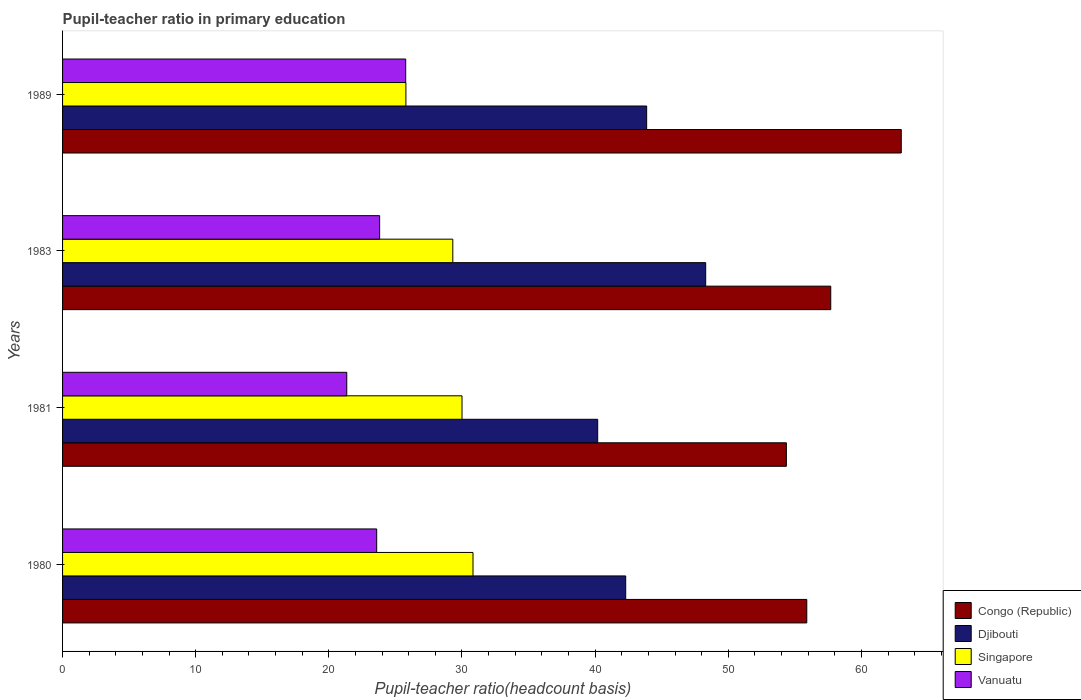How many different coloured bars are there?
Your response must be concise. 4. Are the number of bars per tick equal to the number of legend labels?
Keep it short and to the point. Yes. In how many cases, is the number of bars for a given year not equal to the number of legend labels?
Your response must be concise. 0. What is the pupil-teacher ratio in primary education in Congo (Republic) in 1983?
Make the answer very short. 57.7. Across all years, what is the maximum pupil-teacher ratio in primary education in Congo (Republic)?
Keep it short and to the point. 63. Across all years, what is the minimum pupil-teacher ratio in primary education in Congo (Republic)?
Offer a very short reply. 54.37. What is the total pupil-teacher ratio in primary education in Vanuatu in the graph?
Provide a succinct answer. 94.53. What is the difference between the pupil-teacher ratio in primary education in Vanuatu in 1980 and that in 1981?
Your response must be concise. 2.25. What is the difference between the pupil-teacher ratio in primary education in Congo (Republic) in 1983 and the pupil-teacher ratio in primary education in Djibouti in 1989?
Offer a very short reply. 13.83. What is the average pupil-teacher ratio in primary education in Singapore per year?
Provide a short and direct response. 28.98. In the year 1981, what is the difference between the pupil-teacher ratio in primary education in Vanuatu and pupil-teacher ratio in primary education in Djibouti?
Provide a succinct answer. -18.85. In how many years, is the pupil-teacher ratio in primary education in Djibouti greater than 54 ?
Ensure brevity in your answer.  0. What is the ratio of the pupil-teacher ratio in primary education in Vanuatu in 1980 to that in 1983?
Your answer should be compact. 0.99. Is the pupil-teacher ratio in primary education in Congo (Republic) in 1980 less than that in 1981?
Give a very brief answer. No. Is the difference between the pupil-teacher ratio in primary education in Vanuatu in 1980 and 1983 greater than the difference between the pupil-teacher ratio in primary education in Djibouti in 1980 and 1983?
Provide a succinct answer. Yes. What is the difference between the highest and the second highest pupil-teacher ratio in primary education in Djibouti?
Your answer should be very brief. 4.43. What is the difference between the highest and the lowest pupil-teacher ratio in primary education in Singapore?
Make the answer very short. 5.04. Is the sum of the pupil-teacher ratio in primary education in Singapore in 1981 and 1989 greater than the maximum pupil-teacher ratio in primary education in Djibouti across all years?
Keep it short and to the point. Yes. Is it the case that in every year, the sum of the pupil-teacher ratio in primary education in Singapore and pupil-teacher ratio in primary education in Congo (Republic) is greater than the sum of pupil-teacher ratio in primary education in Vanuatu and pupil-teacher ratio in primary education in Djibouti?
Make the answer very short. No. What does the 1st bar from the top in 1983 represents?
Offer a very short reply. Vanuatu. What does the 3rd bar from the bottom in 1981 represents?
Provide a succinct answer. Singapore. Is it the case that in every year, the sum of the pupil-teacher ratio in primary education in Congo (Republic) and pupil-teacher ratio in primary education in Djibouti is greater than the pupil-teacher ratio in primary education in Vanuatu?
Ensure brevity in your answer.  Yes. How many bars are there?
Keep it short and to the point. 16. What is the difference between two consecutive major ticks on the X-axis?
Offer a terse response. 10. Does the graph contain any zero values?
Your answer should be very brief. No. Does the graph contain grids?
Your response must be concise. No. What is the title of the graph?
Ensure brevity in your answer.  Pupil-teacher ratio in primary education. What is the label or title of the X-axis?
Offer a very short reply. Pupil-teacher ratio(headcount basis). What is the label or title of the Y-axis?
Keep it short and to the point. Years. What is the Pupil-teacher ratio(headcount basis) of Congo (Republic) in 1980?
Your response must be concise. 55.9. What is the Pupil-teacher ratio(headcount basis) of Djibouti in 1980?
Provide a short and direct response. 42.3. What is the Pupil-teacher ratio(headcount basis) of Singapore in 1980?
Make the answer very short. 30.83. What is the Pupil-teacher ratio(headcount basis) in Vanuatu in 1980?
Your answer should be compact. 23.59. What is the Pupil-teacher ratio(headcount basis) in Congo (Republic) in 1981?
Make the answer very short. 54.37. What is the Pupil-teacher ratio(headcount basis) in Djibouti in 1981?
Provide a succinct answer. 40.19. What is the Pupil-teacher ratio(headcount basis) of Singapore in 1981?
Your answer should be very brief. 30. What is the Pupil-teacher ratio(headcount basis) in Vanuatu in 1981?
Your response must be concise. 21.35. What is the Pupil-teacher ratio(headcount basis) of Congo (Republic) in 1983?
Give a very brief answer. 57.7. What is the Pupil-teacher ratio(headcount basis) of Djibouti in 1983?
Provide a short and direct response. 48.3. What is the Pupil-teacher ratio(headcount basis) in Singapore in 1983?
Your answer should be very brief. 29.31. What is the Pupil-teacher ratio(headcount basis) in Vanuatu in 1983?
Offer a very short reply. 23.82. What is the Pupil-teacher ratio(headcount basis) in Congo (Republic) in 1989?
Give a very brief answer. 63. What is the Pupil-teacher ratio(headcount basis) in Djibouti in 1989?
Give a very brief answer. 43.87. What is the Pupil-teacher ratio(headcount basis) in Singapore in 1989?
Your answer should be compact. 25.79. What is the Pupil-teacher ratio(headcount basis) of Vanuatu in 1989?
Ensure brevity in your answer.  25.77. Across all years, what is the maximum Pupil-teacher ratio(headcount basis) of Congo (Republic)?
Offer a very short reply. 63. Across all years, what is the maximum Pupil-teacher ratio(headcount basis) in Djibouti?
Give a very brief answer. 48.3. Across all years, what is the maximum Pupil-teacher ratio(headcount basis) in Singapore?
Ensure brevity in your answer.  30.83. Across all years, what is the maximum Pupil-teacher ratio(headcount basis) of Vanuatu?
Give a very brief answer. 25.77. Across all years, what is the minimum Pupil-teacher ratio(headcount basis) of Congo (Republic)?
Ensure brevity in your answer.  54.37. Across all years, what is the minimum Pupil-teacher ratio(headcount basis) in Djibouti?
Keep it short and to the point. 40.19. Across all years, what is the minimum Pupil-teacher ratio(headcount basis) of Singapore?
Offer a terse response. 25.79. Across all years, what is the minimum Pupil-teacher ratio(headcount basis) in Vanuatu?
Provide a succinct answer. 21.35. What is the total Pupil-teacher ratio(headcount basis) of Congo (Republic) in the graph?
Your answer should be compact. 230.96. What is the total Pupil-teacher ratio(headcount basis) of Djibouti in the graph?
Keep it short and to the point. 174.67. What is the total Pupil-teacher ratio(headcount basis) of Singapore in the graph?
Your answer should be very brief. 115.93. What is the total Pupil-teacher ratio(headcount basis) in Vanuatu in the graph?
Ensure brevity in your answer.  94.53. What is the difference between the Pupil-teacher ratio(headcount basis) in Congo (Republic) in 1980 and that in 1981?
Offer a very short reply. 1.53. What is the difference between the Pupil-teacher ratio(headcount basis) in Djibouti in 1980 and that in 1981?
Offer a terse response. 2.1. What is the difference between the Pupil-teacher ratio(headcount basis) in Singapore in 1980 and that in 1981?
Ensure brevity in your answer.  0.82. What is the difference between the Pupil-teacher ratio(headcount basis) in Vanuatu in 1980 and that in 1981?
Offer a very short reply. 2.25. What is the difference between the Pupil-teacher ratio(headcount basis) of Congo (Republic) in 1980 and that in 1983?
Your response must be concise. -1.8. What is the difference between the Pupil-teacher ratio(headcount basis) of Djibouti in 1980 and that in 1983?
Your answer should be compact. -6.01. What is the difference between the Pupil-teacher ratio(headcount basis) in Singapore in 1980 and that in 1983?
Provide a succinct answer. 1.52. What is the difference between the Pupil-teacher ratio(headcount basis) in Vanuatu in 1980 and that in 1983?
Keep it short and to the point. -0.22. What is the difference between the Pupil-teacher ratio(headcount basis) of Congo (Republic) in 1980 and that in 1989?
Offer a terse response. -7.1. What is the difference between the Pupil-teacher ratio(headcount basis) of Djibouti in 1980 and that in 1989?
Provide a short and direct response. -1.57. What is the difference between the Pupil-teacher ratio(headcount basis) in Singapore in 1980 and that in 1989?
Provide a short and direct response. 5.04. What is the difference between the Pupil-teacher ratio(headcount basis) in Vanuatu in 1980 and that in 1989?
Your answer should be very brief. -2.18. What is the difference between the Pupil-teacher ratio(headcount basis) in Congo (Republic) in 1981 and that in 1983?
Provide a succinct answer. -3.33. What is the difference between the Pupil-teacher ratio(headcount basis) of Djibouti in 1981 and that in 1983?
Your response must be concise. -8.11. What is the difference between the Pupil-teacher ratio(headcount basis) of Singapore in 1981 and that in 1983?
Your answer should be compact. 0.69. What is the difference between the Pupil-teacher ratio(headcount basis) of Vanuatu in 1981 and that in 1983?
Your answer should be very brief. -2.47. What is the difference between the Pupil-teacher ratio(headcount basis) in Congo (Republic) in 1981 and that in 1989?
Make the answer very short. -8.63. What is the difference between the Pupil-teacher ratio(headcount basis) of Djibouti in 1981 and that in 1989?
Your response must be concise. -3.68. What is the difference between the Pupil-teacher ratio(headcount basis) of Singapore in 1981 and that in 1989?
Give a very brief answer. 4.21. What is the difference between the Pupil-teacher ratio(headcount basis) in Vanuatu in 1981 and that in 1989?
Your answer should be compact. -4.43. What is the difference between the Pupil-teacher ratio(headcount basis) in Congo (Republic) in 1983 and that in 1989?
Your response must be concise. -5.3. What is the difference between the Pupil-teacher ratio(headcount basis) of Djibouti in 1983 and that in 1989?
Offer a terse response. 4.43. What is the difference between the Pupil-teacher ratio(headcount basis) of Singapore in 1983 and that in 1989?
Offer a terse response. 3.52. What is the difference between the Pupil-teacher ratio(headcount basis) of Vanuatu in 1983 and that in 1989?
Provide a succinct answer. -1.96. What is the difference between the Pupil-teacher ratio(headcount basis) in Congo (Republic) in 1980 and the Pupil-teacher ratio(headcount basis) in Djibouti in 1981?
Offer a terse response. 15.71. What is the difference between the Pupil-teacher ratio(headcount basis) of Congo (Republic) in 1980 and the Pupil-teacher ratio(headcount basis) of Singapore in 1981?
Provide a short and direct response. 25.9. What is the difference between the Pupil-teacher ratio(headcount basis) in Congo (Republic) in 1980 and the Pupil-teacher ratio(headcount basis) in Vanuatu in 1981?
Give a very brief answer. 34.55. What is the difference between the Pupil-teacher ratio(headcount basis) of Djibouti in 1980 and the Pupil-teacher ratio(headcount basis) of Singapore in 1981?
Your answer should be compact. 12.29. What is the difference between the Pupil-teacher ratio(headcount basis) in Djibouti in 1980 and the Pupil-teacher ratio(headcount basis) in Vanuatu in 1981?
Make the answer very short. 20.95. What is the difference between the Pupil-teacher ratio(headcount basis) of Singapore in 1980 and the Pupil-teacher ratio(headcount basis) of Vanuatu in 1981?
Your answer should be compact. 9.48. What is the difference between the Pupil-teacher ratio(headcount basis) of Congo (Republic) in 1980 and the Pupil-teacher ratio(headcount basis) of Djibouti in 1983?
Keep it short and to the point. 7.59. What is the difference between the Pupil-teacher ratio(headcount basis) of Congo (Republic) in 1980 and the Pupil-teacher ratio(headcount basis) of Singapore in 1983?
Offer a terse response. 26.59. What is the difference between the Pupil-teacher ratio(headcount basis) of Congo (Republic) in 1980 and the Pupil-teacher ratio(headcount basis) of Vanuatu in 1983?
Your answer should be compact. 32.08. What is the difference between the Pupil-teacher ratio(headcount basis) of Djibouti in 1980 and the Pupil-teacher ratio(headcount basis) of Singapore in 1983?
Your response must be concise. 12.99. What is the difference between the Pupil-teacher ratio(headcount basis) of Djibouti in 1980 and the Pupil-teacher ratio(headcount basis) of Vanuatu in 1983?
Give a very brief answer. 18.48. What is the difference between the Pupil-teacher ratio(headcount basis) in Singapore in 1980 and the Pupil-teacher ratio(headcount basis) in Vanuatu in 1983?
Your answer should be compact. 7.01. What is the difference between the Pupil-teacher ratio(headcount basis) in Congo (Republic) in 1980 and the Pupil-teacher ratio(headcount basis) in Djibouti in 1989?
Provide a succinct answer. 12.03. What is the difference between the Pupil-teacher ratio(headcount basis) in Congo (Republic) in 1980 and the Pupil-teacher ratio(headcount basis) in Singapore in 1989?
Make the answer very short. 30.11. What is the difference between the Pupil-teacher ratio(headcount basis) of Congo (Republic) in 1980 and the Pupil-teacher ratio(headcount basis) of Vanuatu in 1989?
Your response must be concise. 30.13. What is the difference between the Pupil-teacher ratio(headcount basis) of Djibouti in 1980 and the Pupil-teacher ratio(headcount basis) of Singapore in 1989?
Offer a terse response. 16.51. What is the difference between the Pupil-teacher ratio(headcount basis) in Djibouti in 1980 and the Pupil-teacher ratio(headcount basis) in Vanuatu in 1989?
Ensure brevity in your answer.  16.52. What is the difference between the Pupil-teacher ratio(headcount basis) of Singapore in 1980 and the Pupil-teacher ratio(headcount basis) of Vanuatu in 1989?
Your answer should be compact. 5.05. What is the difference between the Pupil-teacher ratio(headcount basis) in Congo (Republic) in 1981 and the Pupil-teacher ratio(headcount basis) in Djibouti in 1983?
Provide a succinct answer. 6.06. What is the difference between the Pupil-teacher ratio(headcount basis) in Congo (Republic) in 1981 and the Pupil-teacher ratio(headcount basis) in Singapore in 1983?
Offer a very short reply. 25.05. What is the difference between the Pupil-teacher ratio(headcount basis) of Congo (Republic) in 1981 and the Pupil-teacher ratio(headcount basis) of Vanuatu in 1983?
Your answer should be very brief. 30.55. What is the difference between the Pupil-teacher ratio(headcount basis) of Djibouti in 1981 and the Pupil-teacher ratio(headcount basis) of Singapore in 1983?
Your response must be concise. 10.88. What is the difference between the Pupil-teacher ratio(headcount basis) in Djibouti in 1981 and the Pupil-teacher ratio(headcount basis) in Vanuatu in 1983?
Provide a succinct answer. 16.38. What is the difference between the Pupil-teacher ratio(headcount basis) of Singapore in 1981 and the Pupil-teacher ratio(headcount basis) of Vanuatu in 1983?
Provide a succinct answer. 6.19. What is the difference between the Pupil-teacher ratio(headcount basis) of Congo (Republic) in 1981 and the Pupil-teacher ratio(headcount basis) of Djibouti in 1989?
Ensure brevity in your answer.  10.49. What is the difference between the Pupil-teacher ratio(headcount basis) of Congo (Republic) in 1981 and the Pupil-teacher ratio(headcount basis) of Singapore in 1989?
Offer a very short reply. 28.58. What is the difference between the Pupil-teacher ratio(headcount basis) in Congo (Republic) in 1981 and the Pupil-teacher ratio(headcount basis) in Vanuatu in 1989?
Your answer should be very brief. 28.59. What is the difference between the Pupil-teacher ratio(headcount basis) in Djibouti in 1981 and the Pupil-teacher ratio(headcount basis) in Singapore in 1989?
Offer a very short reply. 14.4. What is the difference between the Pupil-teacher ratio(headcount basis) in Djibouti in 1981 and the Pupil-teacher ratio(headcount basis) in Vanuatu in 1989?
Offer a terse response. 14.42. What is the difference between the Pupil-teacher ratio(headcount basis) in Singapore in 1981 and the Pupil-teacher ratio(headcount basis) in Vanuatu in 1989?
Your answer should be very brief. 4.23. What is the difference between the Pupil-teacher ratio(headcount basis) in Congo (Republic) in 1983 and the Pupil-teacher ratio(headcount basis) in Djibouti in 1989?
Provide a short and direct response. 13.83. What is the difference between the Pupil-teacher ratio(headcount basis) in Congo (Republic) in 1983 and the Pupil-teacher ratio(headcount basis) in Singapore in 1989?
Your answer should be compact. 31.91. What is the difference between the Pupil-teacher ratio(headcount basis) of Congo (Republic) in 1983 and the Pupil-teacher ratio(headcount basis) of Vanuatu in 1989?
Offer a terse response. 31.93. What is the difference between the Pupil-teacher ratio(headcount basis) of Djibouti in 1983 and the Pupil-teacher ratio(headcount basis) of Singapore in 1989?
Offer a very short reply. 22.52. What is the difference between the Pupil-teacher ratio(headcount basis) of Djibouti in 1983 and the Pupil-teacher ratio(headcount basis) of Vanuatu in 1989?
Provide a short and direct response. 22.53. What is the difference between the Pupil-teacher ratio(headcount basis) in Singapore in 1983 and the Pupil-teacher ratio(headcount basis) in Vanuatu in 1989?
Provide a succinct answer. 3.54. What is the average Pupil-teacher ratio(headcount basis) of Congo (Republic) per year?
Make the answer very short. 57.74. What is the average Pupil-teacher ratio(headcount basis) in Djibouti per year?
Make the answer very short. 43.67. What is the average Pupil-teacher ratio(headcount basis) in Singapore per year?
Ensure brevity in your answer.  28.98. What is the average Pupil-teacher ratio(headcount basis) of Vanuatu per year?
Your answer should be very brief. 23.63. In the year 1980, what is the difference between the Pupil-teacher ratio(headcount basis) of Congo (Republic) and Pupil-teacher ratio(headcount basis) of Djibouti?
Your answer should be very brief. 13.6. In the year 1980, what is the difference between the Pupil-teacher ratio(headcount basis) of Congo (Republic) and Pupil-teacher ratio(headcount basis) of Singapore?
Give a very brief answer. 25.07. In the year 1980, what is the difference between the Pupil-teacher ratio(headcount basis) of Congo (Republic) and Pupil-teacher ratio(headcount basis) of Vanuatu?
Ensure brevity in your answer.  32.3. In the year 1980, what is the difference between the Pupil-teacher ratio(headcount basis) in Djibouti and Pupil-teacher ratio(headcount basis) in Singapore?
Offer a terse response. 11.47. In the year 1980, what is the difference between the Pupil-teacher ratio(headcount basis) in Djibouti and Pupil-teacher ratio(headcount basis) in Vanuatu?
Make the answer very short. 18.7. In the year 1980, what is the difference between the Pupil-teacher ratio(headcount basis) in Singapore and Pupil-teacher ratio(headcount basis) in Vanuatu?
Give a very brief answer. 7.23. In the year 1981, what is the difference between the Pupil-teacher ratio(headcount basis) in Congo (Republic) and Pupil-teacher ratio(headcount basis) in Djibouti?
Your response must be concise. 14.17. In the year 1981, what is the difference between the Pupil-teacher ratio(headcount basis) in Congo (Republic) and Pupil-teacher ratio(headcount basis) in Singapore?
Your response must be concise. 24.36. In the year 1981, what is the difference between the Pupil-teacher ratio(headcount basis) in Congo (Republic) and Pupil-teacher ratio(headcount basis) in Vanuatu?
Keep it short and to the point. 33.02. In the year 1981, what is the difference between the Pupil-teacher ratio(headcount basis) of Djibouti and Pupil-teacher ratio(headcount basis) of Singapore?
Offer a terse response. 10.19. In the year 1981, what is the difference between the Pupil-teacher ratio(headcount basis) in Djibouti and Pupil-teacher ratio(headcount basis) in Vanuatu?
Your answer should be compact. 18.85. In the year 1981, what is the difference between the Pupil-teacher ratio(headcount basis) of Singapore and Pupil-teacher ratio(headcount basis) of Vanuatu?
Offer a terse response. 8.66. In the year 1983, what is the difference between the Pupil-teacher ratio(headcount basis) of Congo (Republic) and Pupil-teacher ratio(headcount basis) of Djibouti?
Your answer should be very brief. 9.39. In the year 1983, what is the difference between the Pupil-teacher ratio(headcount basis) of Congo (Republic) and Pupil-teacher ratio(headcount basis) of Singapore?
Give a very brief answer. 28.39. In the year 1983, what is the difference between the Pupil-teacher ratio(headcount basis) in Congo (Republic) and Pupil-teacher ratio(headcount basis) in Vanuatu?
Ensure brevity in your answer.  33.88. In the year 1983, what is the difference between the Pupil-teacher ratio(headcount basis) in Djibouti and Pupil-teacher ratio(headcount basis) in Singapore?
Make the answer very short. 18.99. In the year 1983, what is the difference between the Pupil-teacher ratio(headcount basis) in Djibouti and Pupil-teacher ratio(headcount basis) in Vanuatu?
Provide a succinct answer. 24.49. In the year 1983, what is the difference between the Pupil-teacher ratio(headcount basis) in Singapore and Pupil-teacher ratio(headcount basis) in Vanuatu?
Keep it short and to the point. 5.5. In the year 1989, what is the difference between the Pupil-teacher ratio(headcount basis) in Congo (Republic) and Pupil-teacher ratio(headcount basis) in Djibouti?
Your answer should be very brief. 19.12. In the year 1989, what is the difference between the Pupil-teacher ratio(headcount basis) of Congo (Republic) and Pupil-teacher ratio(headcount basis) of Singapore?
Give a very brief answer. 37.21. In the year 1989, what is the difference between the Pupil-teacher ratio(headcount basis) of Congo (Republic) and Pupil-teacher ratio(headcount basis) of Vanuatu?
Offer a very short reply. 37.22. In the year 1989, what is the difference between the Pupil-teacher ratio(headcount basis) in Djibouti and Pupil-teacher ratio(headcount basis) in Singapore?
Your answer should be very brief. 18.08. In the year 1989, what is the difference between the Pupil-teacher ratio(headcount basis) of Djibouti and Pupil-teacher ratio(headcount basis) of Vanuatu?
Provide a succinct answer. 18.1. In the year 1989, what is the difference between the Pupil-teacher ratio(headcount basis) in Singapore and Pupil-teacher ratio(headcount basis) in Vanuatu?
Offer a terse response. 0.02. What is the ratio of the Pupil-teacher ratio(headcount basis) in Congo (Republic) in 1980 to that in 1981?
Offer a very short reply. 1.03. What is the ratio of the Pupil-teacher ratio(headcount basis) of Djibouti in 1980 to that in 1981?
Your answer should be very brief. 1.05. What is the ratio of the Pupil-teacher ratio(headcount basis) in Singapore in 1980 to that in 1981?
Your answer should be compact. 1.03. What is the ratio of the Pupil-teacher ratio(headcount basis) of Vanuatu in 1980 to that in 1981?
Your answer should be very brief. 1.11. What is the ratio of the Pupil-teacher ratio(headcount basis) of Congo (Republic) in 1980 to that in 1983?
Keep it short and to the point. 0.97. What is the ratio of the Pupil-teacher ratio(headcount basis) of Djibouti in 1980 to that in 1983?
Provide a succinct answer. 0.88. What is the ratio of the Pupil-teacher ratio(headcount basis) of Singapore in 1980 to that in 1983?
Offer a very short reply. 1.05. What is the ratio of the Pupil-teacher ratio(headcount basis) in Vanuatu in 1980 to that in 1983?
Your answer should be very brief. 0.99. What is the ratio of the Pupil-teacher ratio(headcount basis) of Congo (Republic) in 1980 to that in 1989?
Provide a succinct answer. 0.89. What is the ratio of the Pupil-teacher ratio(headcount basis) of Djibouti in 1980 to that in 1989?
Make the answer very short. 0.96. What is the ratio of the Pupil-teacher ratio(headcount basis) of Singapore in 1980 to that in 1989?
Your response must be concise. 1.2. What is the ratio of the Pupil-teacher ratio(headcount basis) of Vanuatu in 1980 to that in 1989?
Provide a succinct answer. 0.92. What is the ratio of the Pupil-teacher ratio(headcount basis) in Congo (Republic) in 1981 to that in 1983?
Your response must be concise. 0.94. What is the ratio of the Pupil-teacher ratio(headcount basis) in Djibouti in 1981 to that in 1983?
Offer a very short reply. 0.83. What is the ratio of the Pupil-teacher ratio(headcount basis) of Singapore in 1981 to that in 1983?
Offer a very short reply. 1.02. What is the ratio of the Pupil-teacher ratio(headcount basis) of Vanuatu in 1981 to that in 1983?
Make the answer very short. 0.9. What is the ratio of the Pupil-teacher ratio(headcount basis) in Congo (Republic) in 1981 to that in 1989?
Your answer should be compact. 0.86. What is the ratio of the Pupil-teacher ratio(headcount basis) in Djibouti in 1981 to that in 1989?
Offer a terse response. 0.92. What is the ratio of the Pupil-teacher ratio(headcount basis) of Singapore in 1981 to that in 1989?
Provide a succinct answer. 1.16. What is the ratio of the Pupil-teacher ratio(headcount basis) of Vanuatu in 1981 to that in 1989?
Offer a terse response. 0.83. What is the ratio of the Pupil-teacher ratio(headcount basis) in Congo (Republic) in 1983 to that in 1989?
Keep it short and to the point. 0.92. What is the ratio of the Pupil-teacher ratio(headcount basis) in Djibouti in 1983 to that in 1989?
Your answer should be very brief. 1.1. What is the ratio of the Pupil-teacher ratio(headcount basis) of Singapore in 1983 to that in 1989?
Give a very brief answer. 1.14. What is the ratio of the Pupil-teacher ratio(headcount basis) in Vanuatu in 1983 to that in 1989?
Offer a very short reply. 0.92. What is the difference between the highest and the second highest Pupil-teacher ratio(headcount basis) in Congo (Republic)?
Your answer should be compact. 5.3. What is the difference between the highest and the second highest Pupil-teacher ratio(headcount basis) of Djibouti?
Keep it short and to the point. 4.43. What is the difference between the highest and the second highest Pupil-teacher ratio(headcount basis) in Singapore?
Provide a succinct answer. 0.82. What is the difference between the highest and the second highest Pupil-teacher ratio(headcount basis) of Vanuatu?
Provide a succinct answer. 1.96. What is the difference between the highest and the lowest Pupil-teacher ratio(headcount basis) of Congo (Republic)?
Your response must be concise. 8.63. What is the difference between the highest and the lowest Pupil-teacher ratio(headcount basis) of Djibouti?
Provide a short and direct response. 8.11. What is the difference between the highest and the lowest Pupil-teacher ratio(headcount basis) in Singapore?
Ensure brevity in your answer.  5.04. What is the difference between the highest and the lowest Pupil-teacher ratio(headcount basis) of Vanuatu?
Provide a short and direct response. 4.43. 